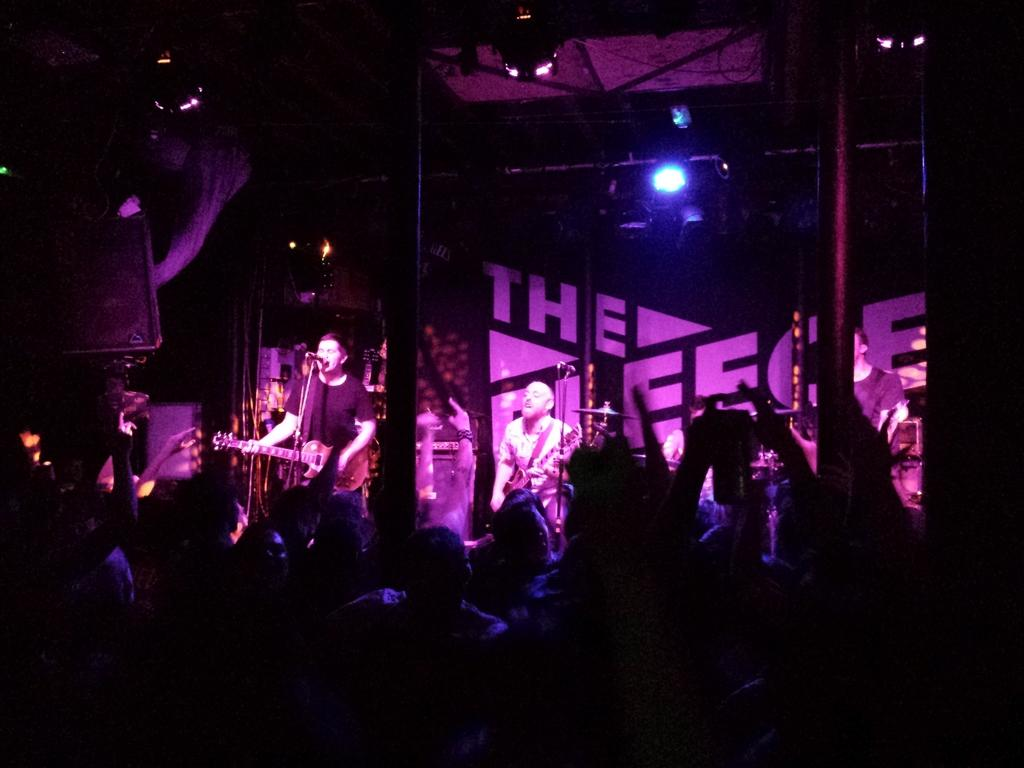How many people are in the image? There are people in the image, but the exact number is not specified. What can be seen besides the people in the image? There are poles, focusing lights, boards, and objects visible in the image. What are some people doing in the image? Some people are playing musical instruments in front of microphones. What type of story is being told by the drawer in the image? There is no drawer present in the image, so no story can be told by a drawer. 